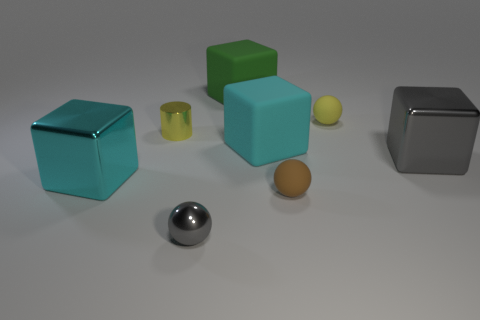There is a small shiny thing behind the large cyan block that is in front of the big metallic block that is on the right side of the cylinder; what color is it?
Your response must be concise. Yellow. The other large rubber thing that is the same shape as the large green thing is what color?
Make the answer very short. Cyan. What is the color of the shiny object that is the same size as the gray ball?
Offer a terse response. Yellow. Do the big gray block and the yellow cylinder have the same material?
Keep it short and to the point. Yes. What number of small objects have the same color as the tiny cylinder?
Make the answer very short. 1. Does the small metal cylinder have the same color as the tiny metallic sphere?
Provide a succinct answer. No. There is a big cyan cube on the left side of the green rubber cube; what is its material?
Ensure brevity in your answer.  Metal. What number of big things are either brown matte spheres or gray blocks?
Make the answer very short. 1. What is the material of the cube that is the same color as the tiny metallic ball?
Provide a succinct answer. Metal. Is there a small red cylinder that has the same material as the green block?
Your response must be concise. No. 